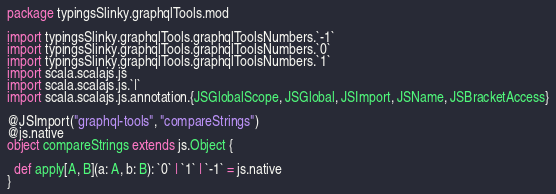Convert code to text. <code><loc_0><loc_0><loc_500><loc_500><_Scala_>package typingsSlinky.graphqlTools.mod

import typingsSlinky.graphqlTools.graphqlToolsNumbers.`-1`
import typingsSlinky.graphqlTools.graphqlToolsNumbers.`0`
import typingsSlinky.graphqlTools.graphqlToolsNumbers.`1`
import scala.scalajs.js
import scala.scalajs.js.`|`
import scala.scalajs.js.annotation.{JSGlobalScope, JSGlobal, JSImport, JSName, JSBracketAccess}

@JSImport("graphql-tools", "compareStrings")
@js.native
object compareStrings extends js.Object {
  
  def apply[A, B](a: A, b: B): `0` | `1` | `-1` = js.native
}
</code> 